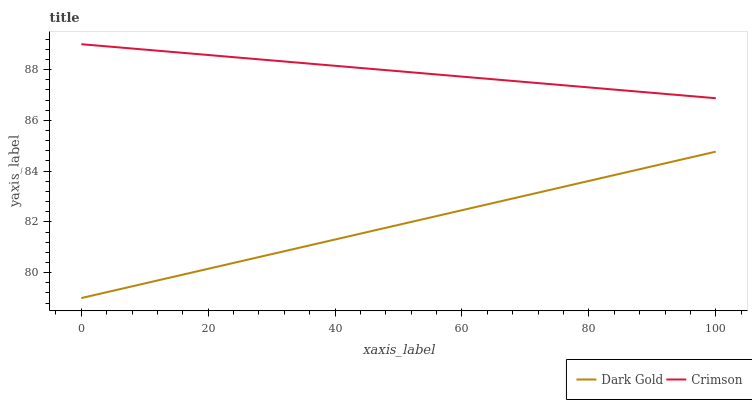Does Dark Gold have the minimum area under the curve?
Answer yes or no. Yes. Does Crimson have the maximum area under the curve?
Answer yes or no. Yes. Does Dark Gold have the maximum area under the curve?
Answer yes or no. No. Is Crimson the smoothest?
Answer yes or no. Yes. Is Dark Gold the roughest?
Answer yes or no. Yes. Is Dark Gold the smoothest?
Answer yes or no. No. Does Dark Gold have the lowest value?
Answer yes or no. Yes. Does Crimson have the highest value?
Answer yes or no. Yes. Does Dark Gold have the highest value?
Answer yes or no. No. Is Dark Gold less than Crimson?
Answer yes or no. Yes. Is Crimson greater than Dark Gold?
Answer yes or no. Yes. Does Dark Gold intersect Crimson?
Answer yes or no. No. 